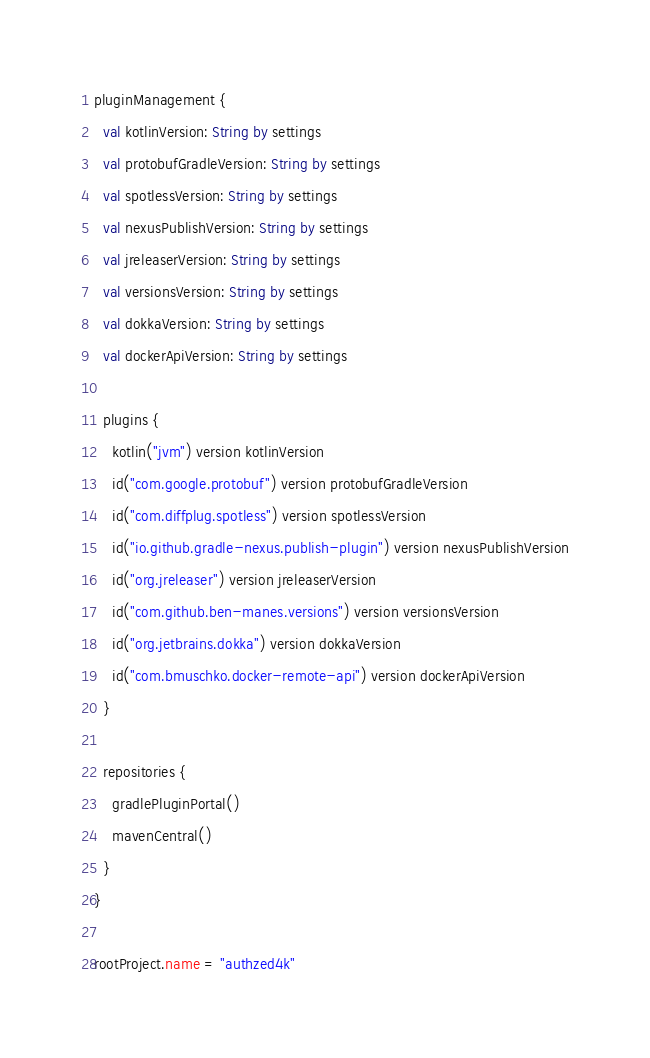Convert code to text. <code><loc_0><loc_0><loc_500><loc_500><_Kotlin_>pluginManagement {
  val kotlinVersion: String by settings
  val protobufGradleVersion: String by settings
  val spotlessVersion: String by settings
  val nexusPublishVersion: String by settings
  val jreleaserVersion: String by settings
  val versionsVersion: String by settings
  val dokkaVersion: String by settings
  val dockerApiVersion: String by settings

  plugins {
    kotlin("jvm") version kotlinVersion
    id("com.google.protobuf") version protobufGradleVersion
    id("com.diffplug.spotless") version spotlessVersion
    id("io.github.gradle-nexus.publish-plugin") version nexusPublishVersion
    id("org.jreleaser") version jreleaserVersion
    id("com.github.ben-manes.versions") version versionsVersion
    id("org.jetbrains.dokka") version dokkaVersion
    id("com.bmuschko.docker-remote-api") version dockerApiVersion
  }

  repositories {
    gradlePluginPortal()
    mavenCentral()
  }
}

rootProject.name = "authzed4k"
</code> 